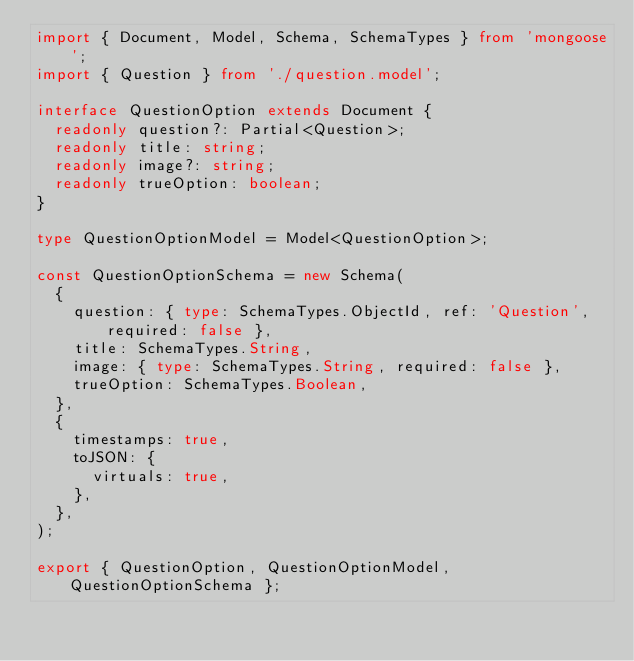Convert code to text. <code><loc_0><loc_0><loc_500><loc_500><_TypeScript_>import { Document, Model, Schema, SchemaTypes } from 'mongoose';
import { Question } from './question.model';

interface QuestionOption extends Document {
  readonly question?: Partial<Question>;
  readonly title: string;
  readonly image?: string;
  readonly trueOption: boolean;
}

type QuestionOptionModel = Model<QuestionOption>;

const QuestionOptionSchema = new Schema(
  {
    question: { type: SchemaTypes.ObjectId, ref: 'Question', required: false },
    title: SchemaTypes.String,
    image: { type: SchemaTypes.String, required: false },
    trueOption: SchemaTypes.Boolean,
  },
  {
    timestamps: true,
    toJSON: {
      virtuals: true,
    },
  },
);

export { QuestionOption, QuestionOptionModel, QuestionOptionSchema };
</code> 